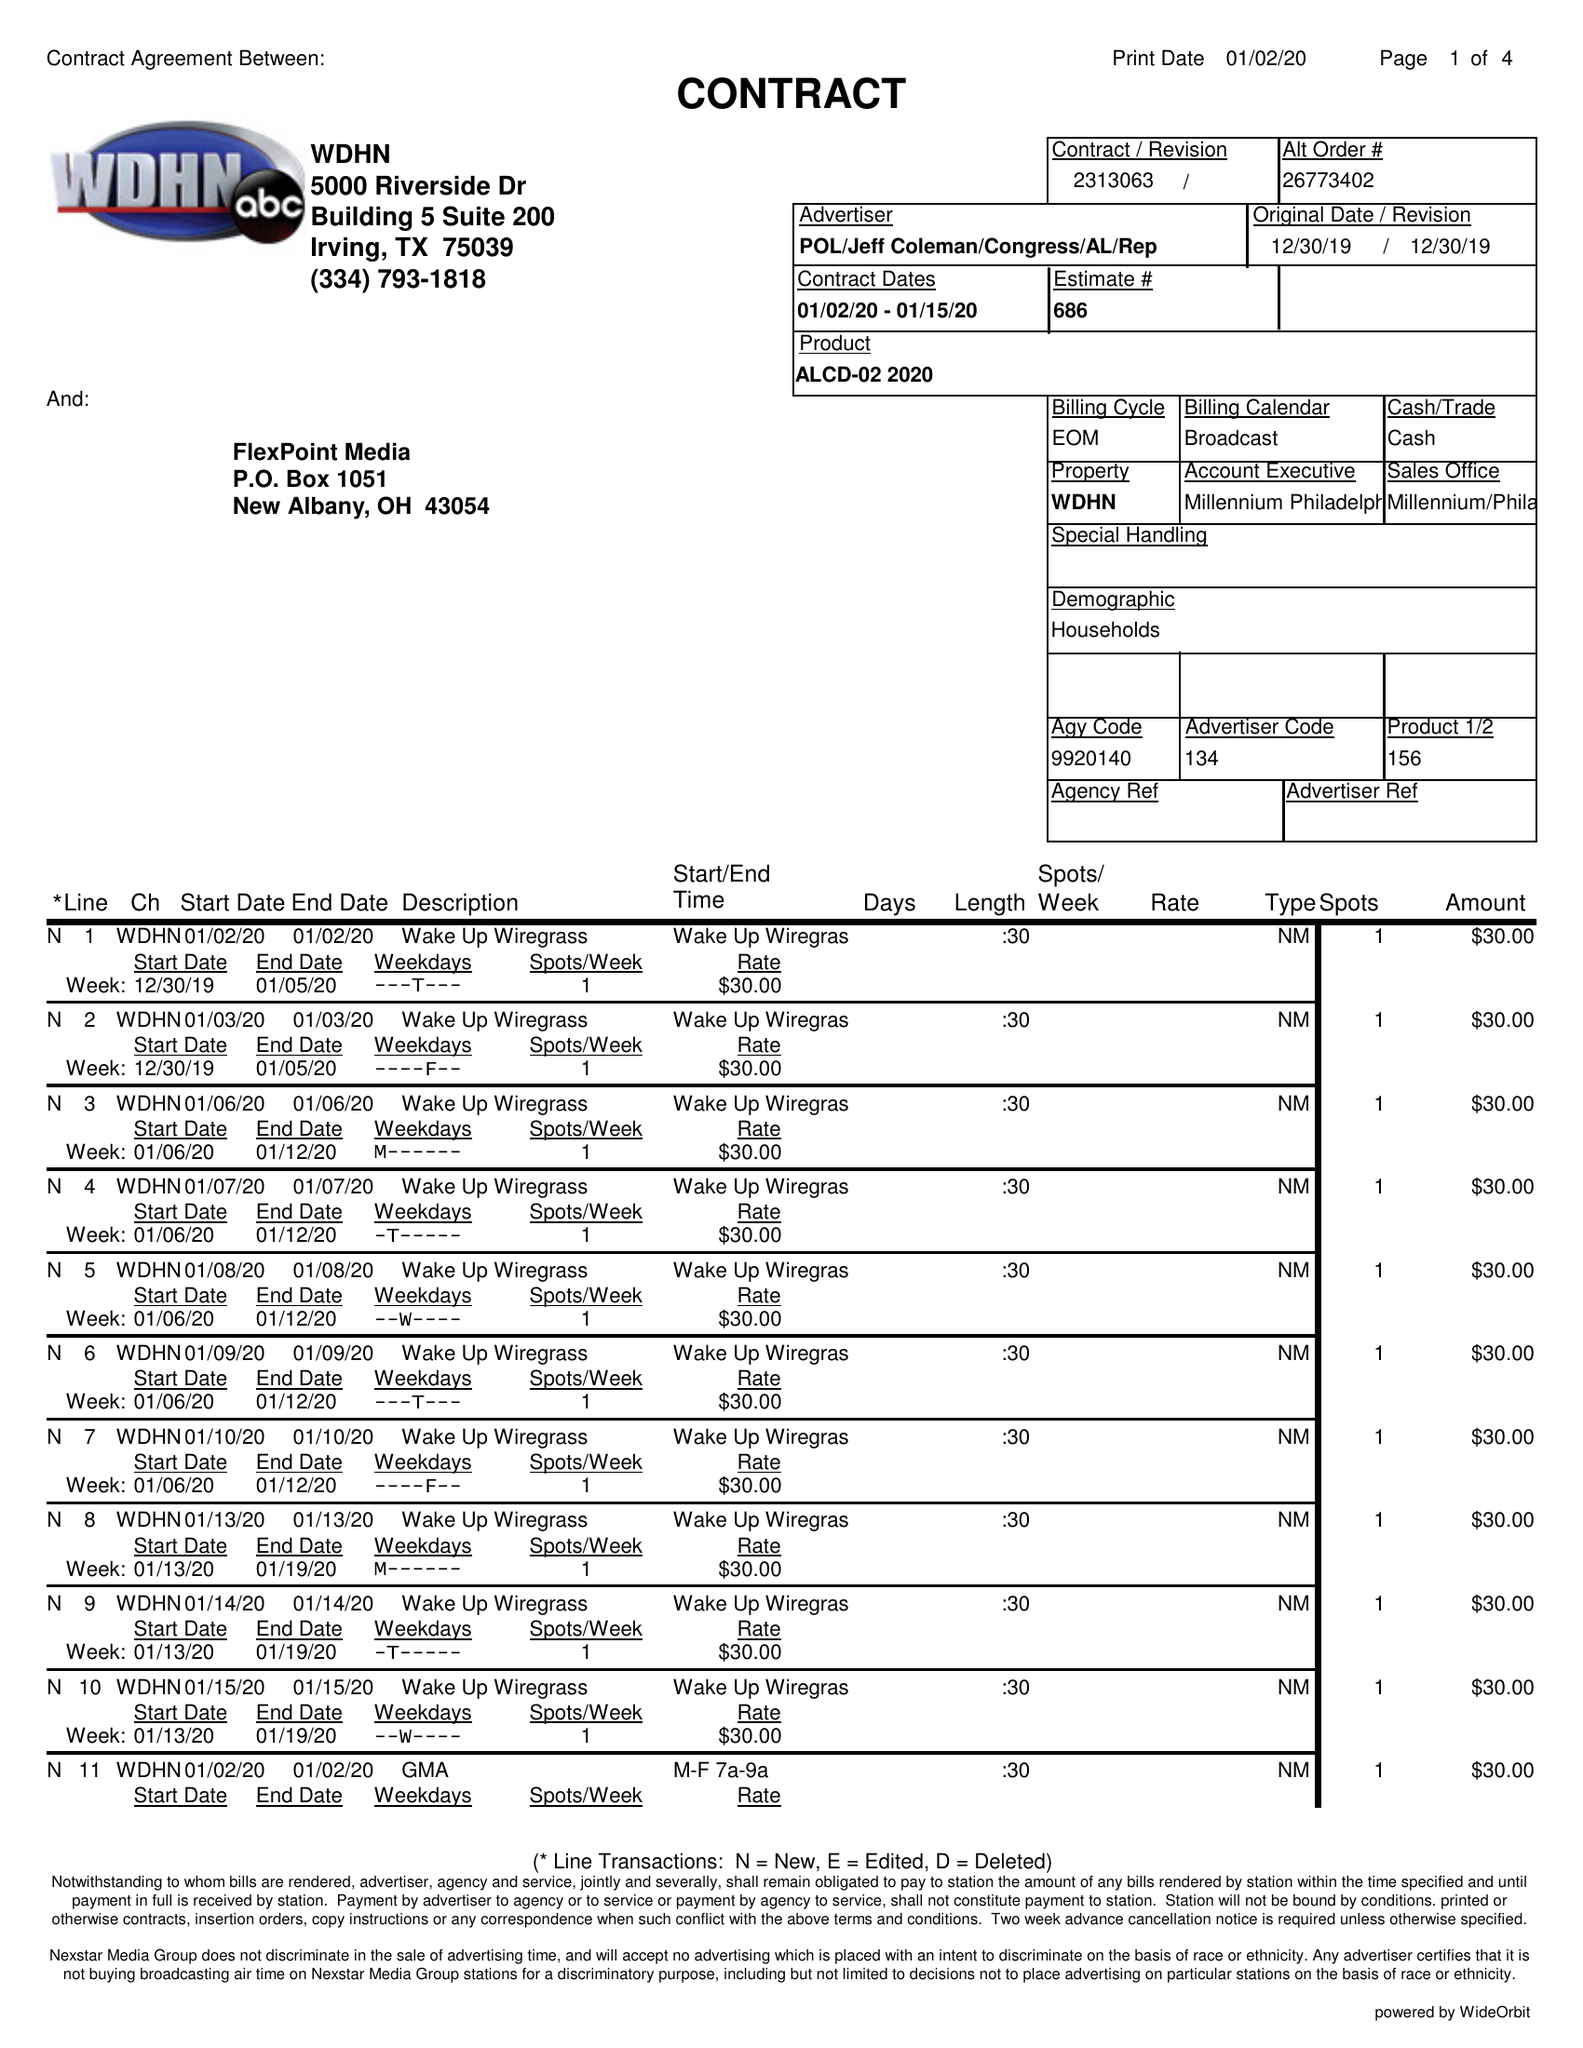What is the value for the contract_num?
Answer the question using a single word or phrase. 2313063 